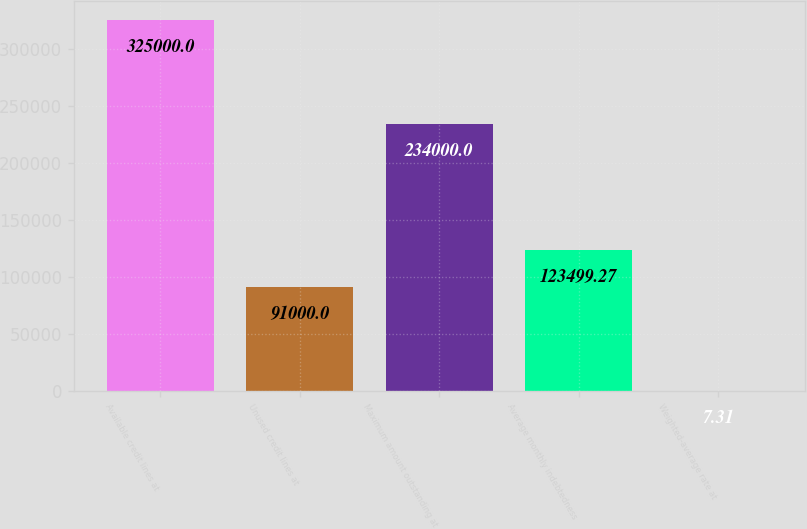<chart> <loc_0><loc_0><loc_500><loc_500><bar_chart><fcel>Available credit lines at<fcel>Unused credit lines at<fcel>Maximum amount outstanding at<fcel>Average monthly indebtedness<fcel>Weighted-average rate at<nl><fcel>325000<fcel>91000<fcel>234000<fcel>123499<fcel>7.31<nl></chart> 